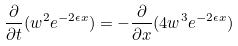<formula> <loc_0><loc_0><loc_500><loc_500>\frac { \partial } { \partial t } ( w ^ { 2 } e ^ { - 2 \epsilon x } ) = - \frac { \partial } { \partial x } ( 4 w ^ { 3 } e ^ { - 2 \epsilon x } )</formula> 